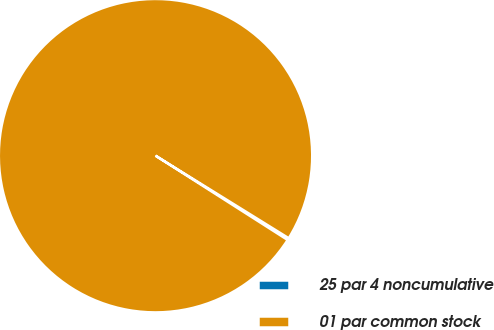Convert chart. <chart><loc_0><loc_0><loc_500><loc_500><pie_chart><fcel>25 par 4 noncumulative<fcel>01 par common stock<nl><fcel>0.21%<fcel>99.79%<nl></chart> 